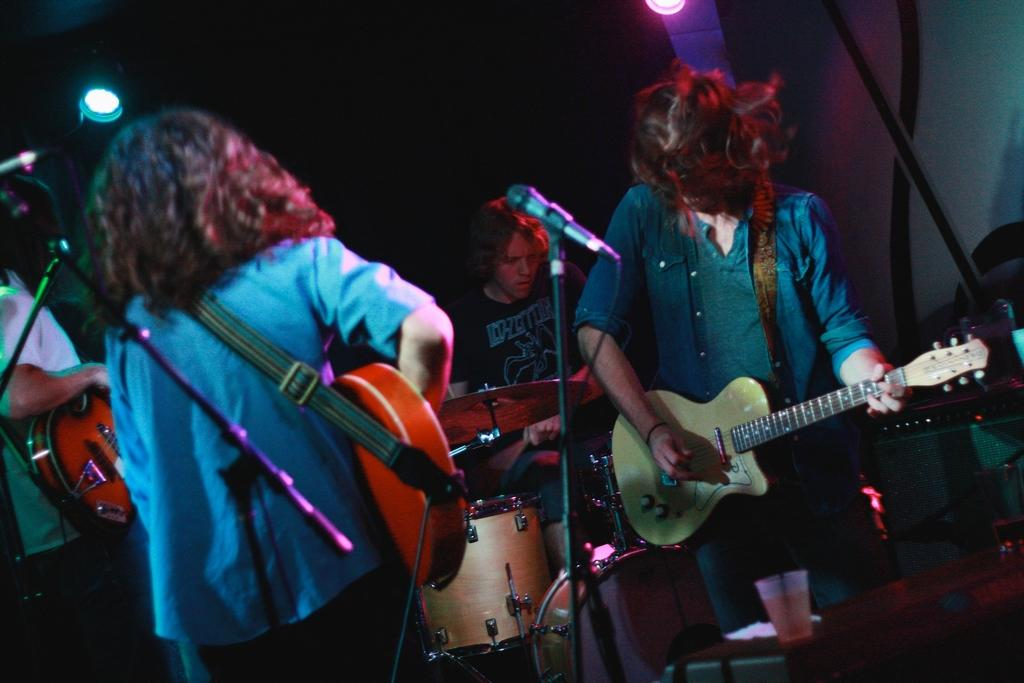How many people are playing musical instruments in the image? There are three persons playing musical instruments in the image. What instruments are being played by the two guitarists? Both of the guitarists are playing guitar. What instrument is being played by the third person? The third person is playing drums. What color is the shirt of the person playing drums? The person playing drums is wearing a black shirt. What type of shade is being used to cover the pump in the image? There is no shade or pump present in the image; it features three persons playing musical instruments. 